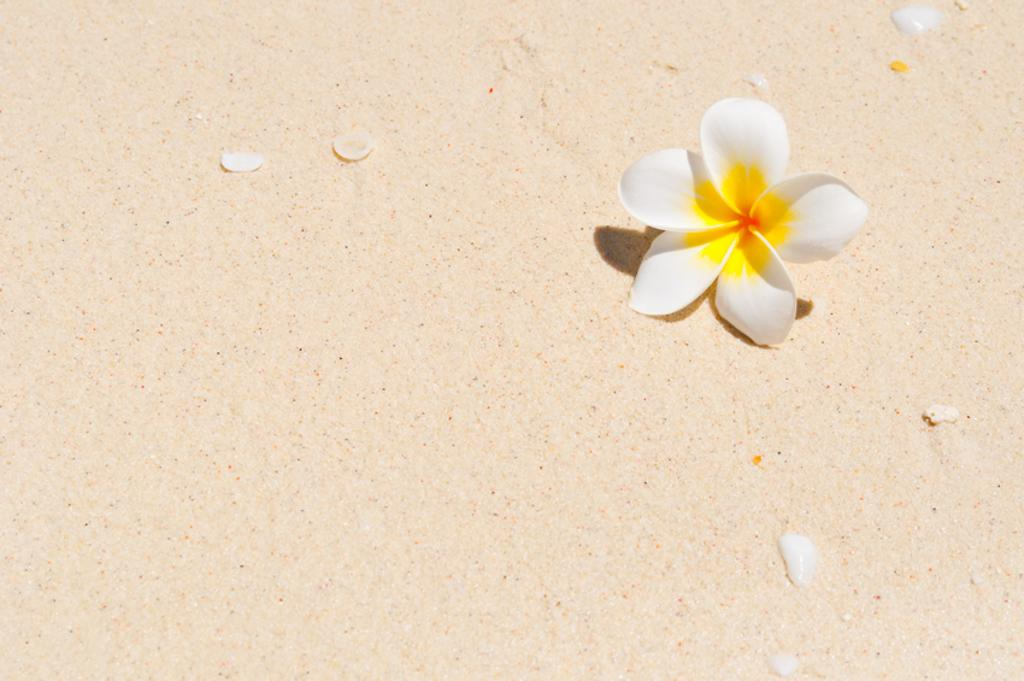What is the main subject of the image? There is a flower in the image. Can you see any fairies interacting with the flower in the image? There is no mention of fairies in the image, and therefore no such interaction can be observed. 